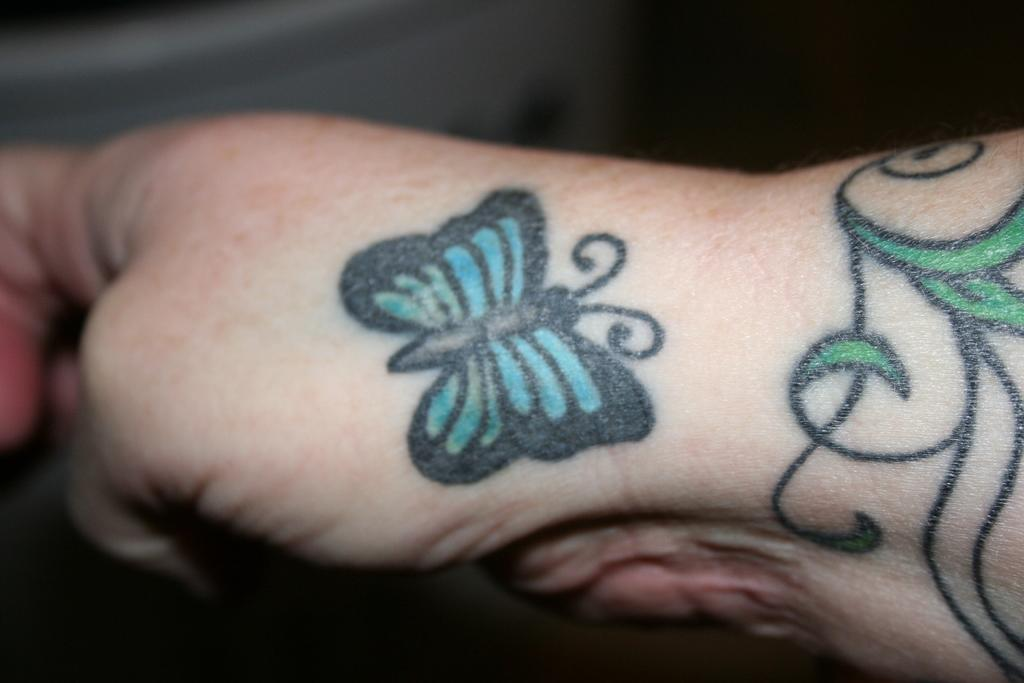What can be seen in the image related to a person's body part? There is a person's hand in the image. Are there any distinguishing features on the hand? Yes, the hand has tattoos on it. What type of paper is the writer using to create the ground in the image? There is no paper, writer, or ground present in the image; it only features a person's hand with tattoos. 